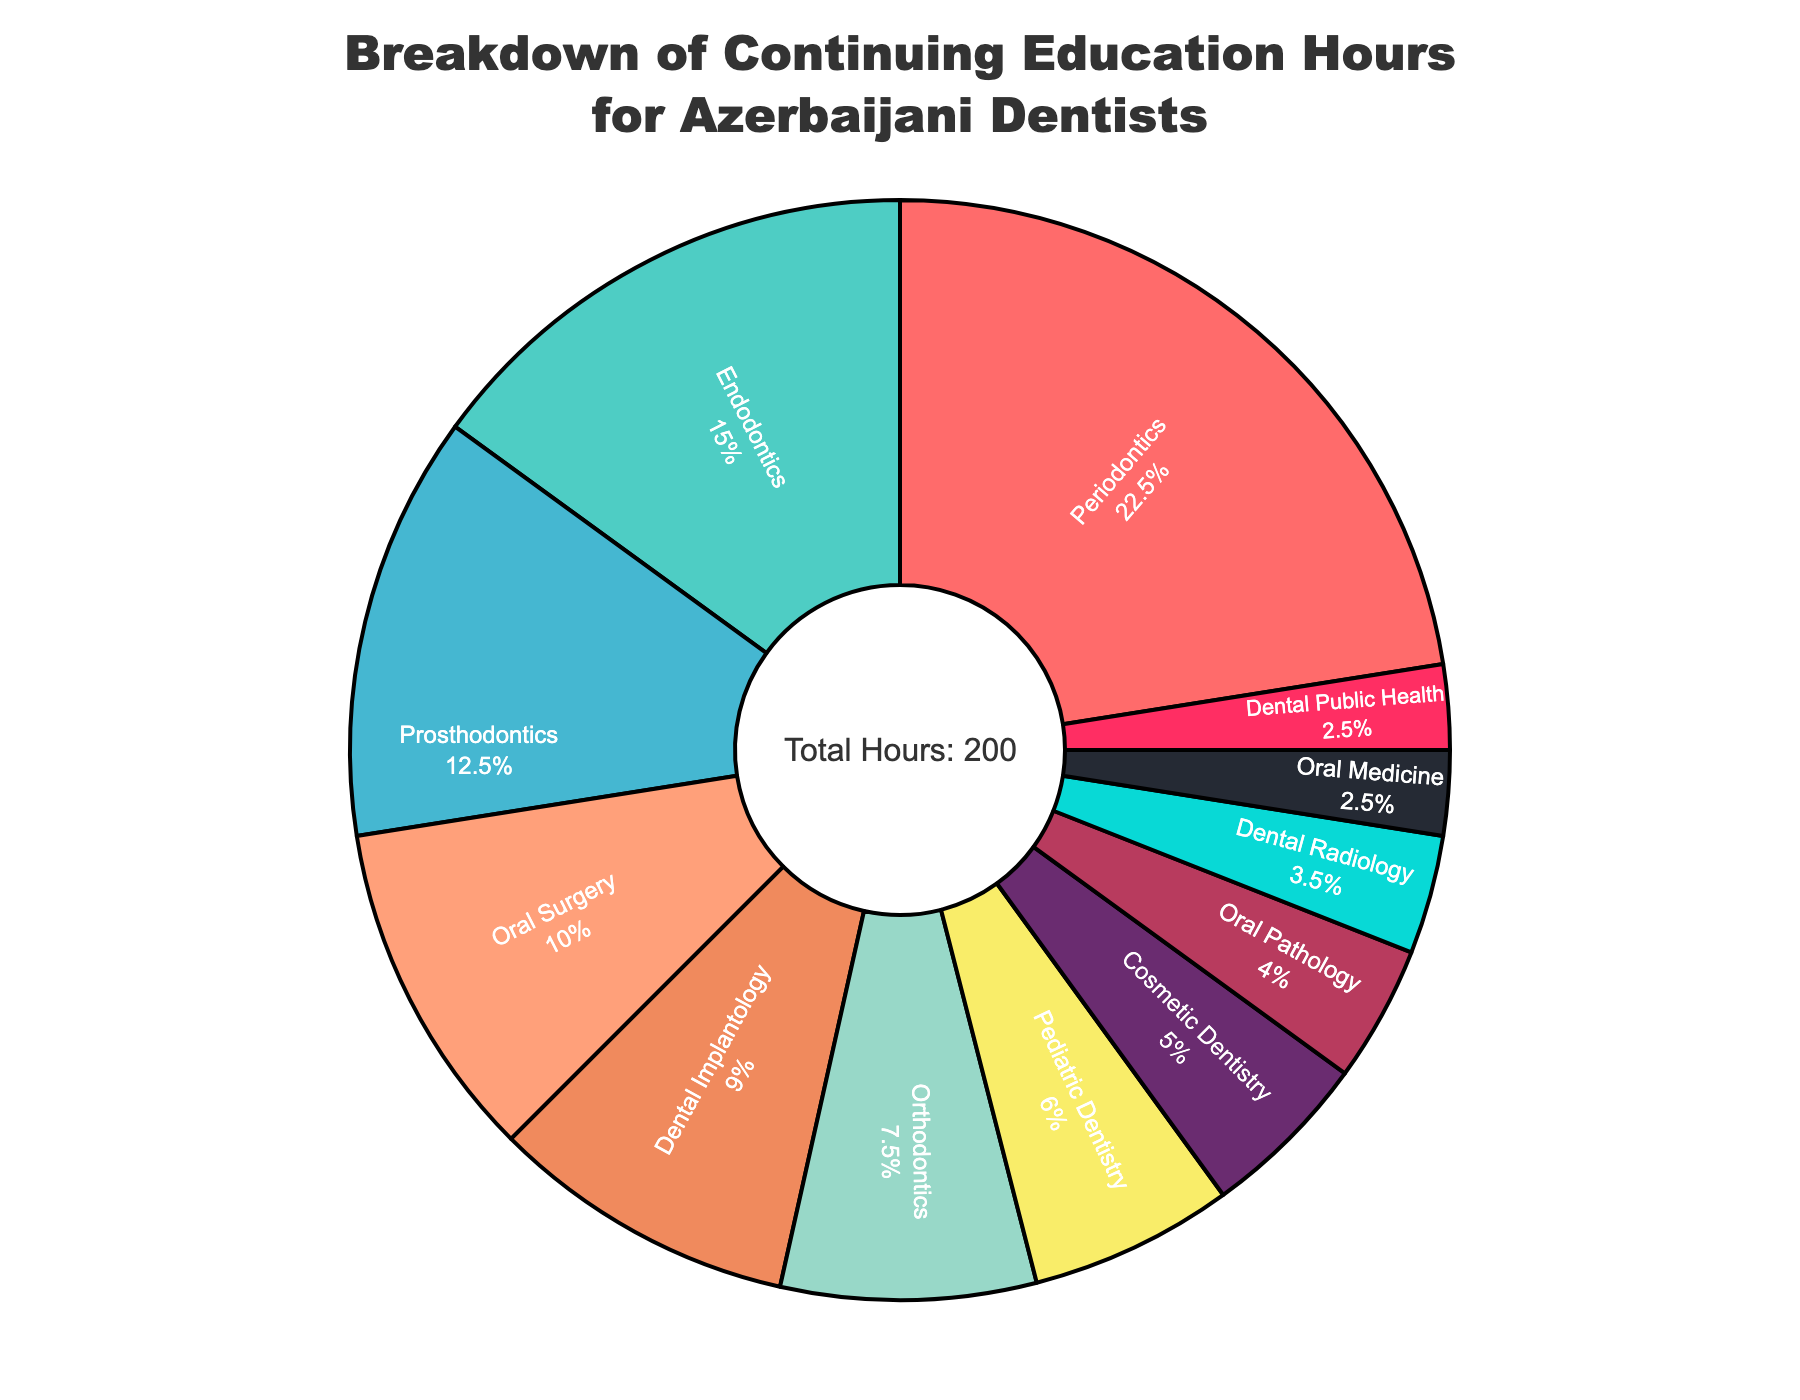What is the total number of continuing education hours spent on Endodontics and Prosthodontics combined? To find the total number of hours spent on Endodontics and Prosthodontics, add the hours for each specialty: 30 hours (Endodontics) + 25 hours (Prosthodontics) = 55 hours.
Answer: 55 hours Which specialty has the highest number of continuing education hours? By looking at the percentages and labels, Periodontics has the highest number of continuing education hours.
Answer: Periodontics How many more hours are spent on Orthodontics compared to Oral Pathology? Subtract the number of hours spent on Oral Pathology (8) from the hours spent on Orthodontics (15): 15 - 8 = 7 hours more are spent on Orthodontics.
Answer: 7 hours What percentage of the total continuing education hours is spent on Cosmetic Dentistry? The chart shows percentages. Cosmetic Dentistry has 10 out of the total hours, corresponding to approximately 4.4% of the total hours (10/230 * 100).
Answer: 4.4% List the specialties with fewer than 10 continuing education hours. By examining each slice of the pie chart, the specialties with fewer than 10 hours are: Oral Pathology (8 hours), Dental Radiology (7 hours), Oral Medicine (5 hours), and Dental Public Health (5 hours).
Answer: Oral Pathology, Dental Radiology, Oral Medicine, Dental Public Health Compare the number of hours spent on Dental Implantology and Oral Surgery. Which specialty has more hours, and by how many? Dental Implantology has 18 hours and Oral Surgery has 20 hours. Oral Surgery has 2 more hours: 20 - 18 = 2 hours.
Answer: Oral Surgery by 2 hours Which specialty is represented by the smallest slice in the pie chart? The smallest slice in the pie chart corresponds to the specialty with the least hours. Oral Medicine and Dental Public Health both have the smallest slice with 5 hours each.
Answer: Oral Medicine, Dental Public Health What's the difference in the number of hours between Prosthodontics and Pediatric Dentistry? Subtract the number of hours for Pediatric Dentistry (12) from Prosthodontics (25): 25 - 12 = 13 hours.
Answer: 13 hours What is the visual attribute used to display the percentage of total hours for each specialty? The pie chart uses the size of each slice to represent the percentage of the total hours for each specialty.
Answer: Size of each slice Which color represents the specialty with the highest number of hours? The portion with the largest size and the color it represents will correspond to Periodontics, which is the specialty with the highest number of hours. The specific color might depend on the color scheme but is likely specified in the palette.
Answer: (Specific color from the chart which represents Periodontics) 